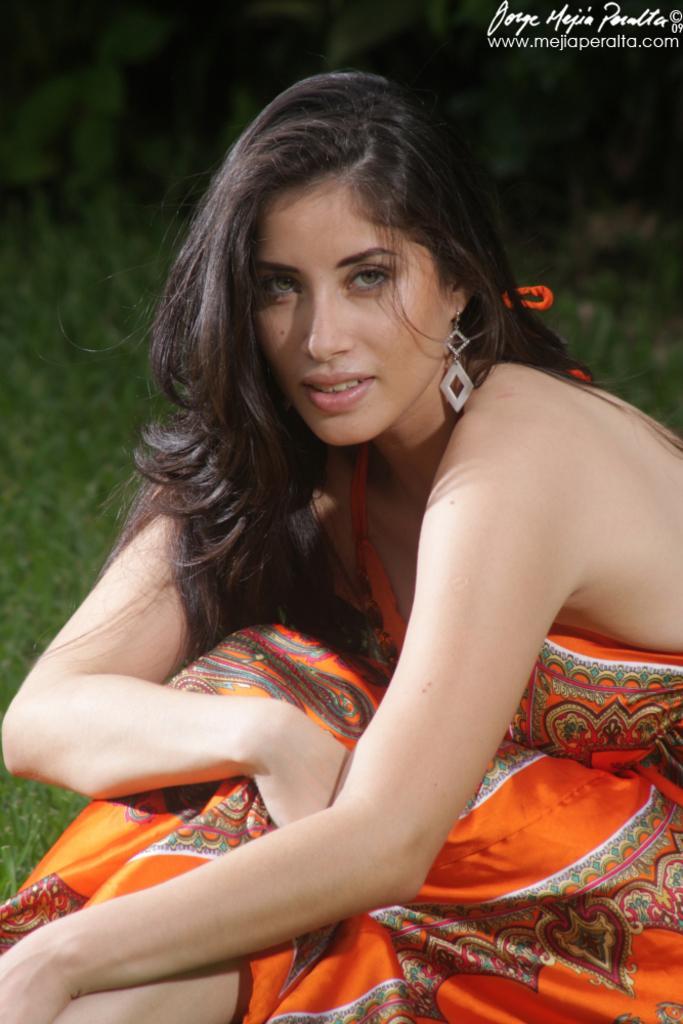In one or two sentences, can you explain what this image depicts? In this image we can see a lady wearing orange dress and a earring. In the background it is green. In the right top corner there is a watermark. 